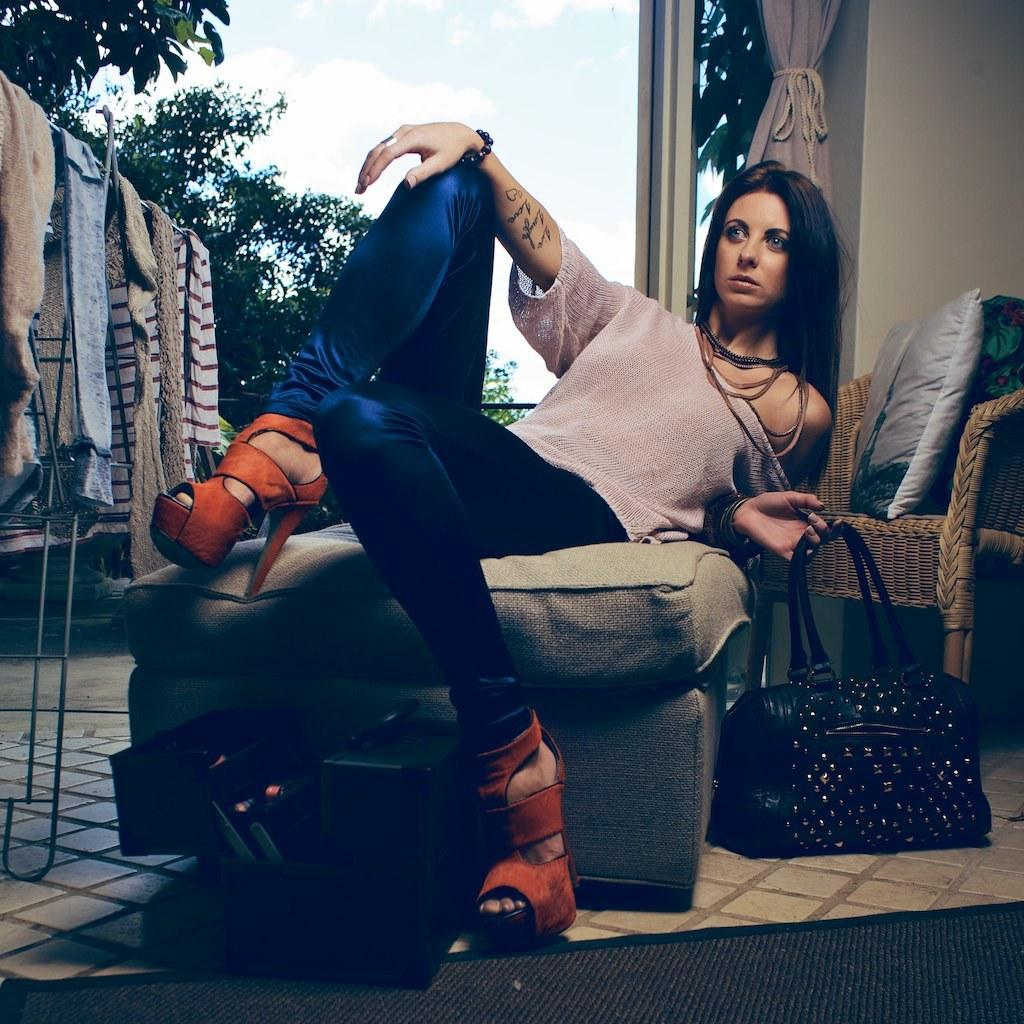Who is present in the image? There is a woman in the image. What is the woman doing in the image? The woman is leaning on a sofa. What is the woman holding in her hand? The woman is holding a bag in her hand. What can be seen in the background of the image? There are clothes, trees, clouds, a chair with pillows, and curtains visible in the background. What is the condition of the sky in the image? The sky is visible in the background, and there are clouds present. What type of toys can be seen on the floor in the image? There are no toys visible on the floor in the image. 